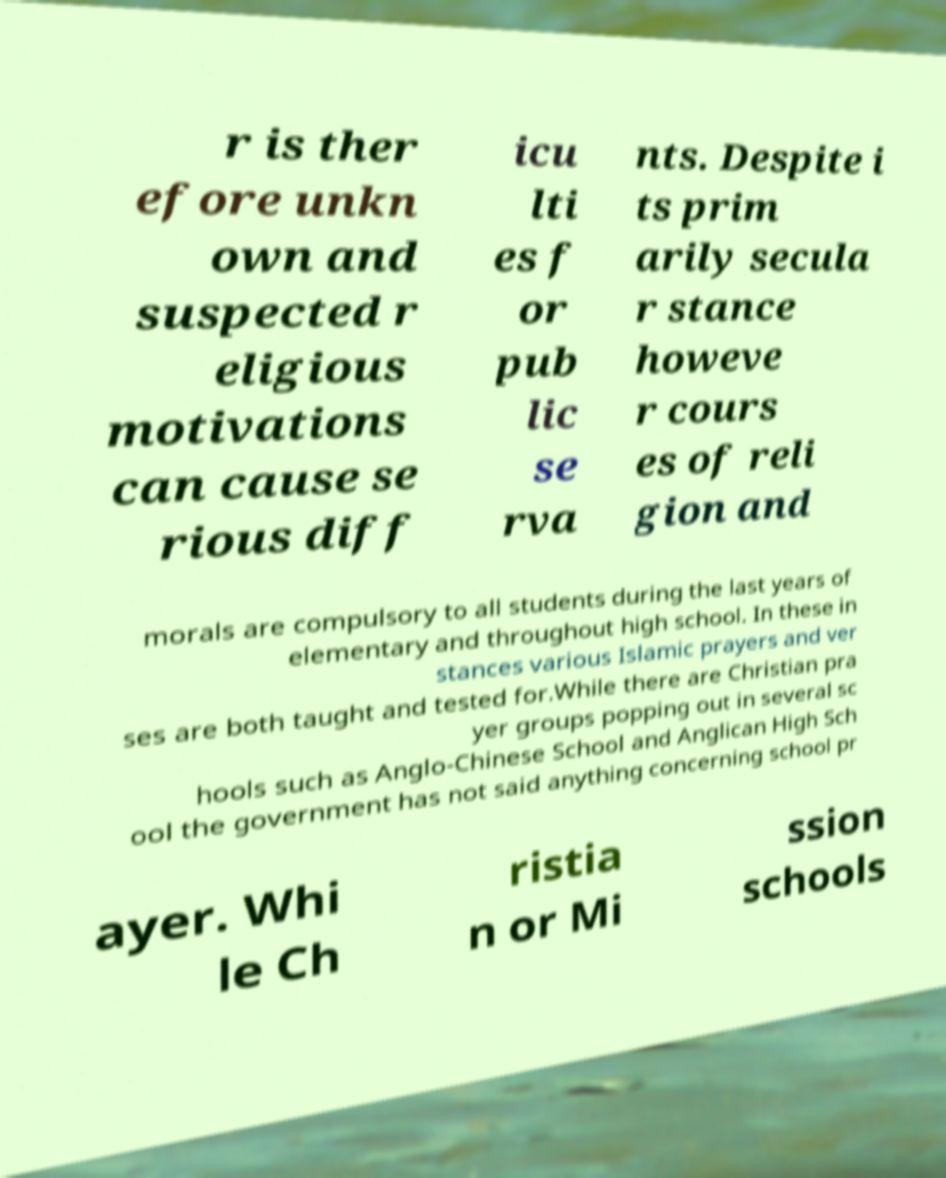I need the written content from this picture converted into text. Can you do that? r is ther efore unkn own and suspected r eligious motivations can cause se rious diff icu lti es f or pub lic se rva nts. Despite i ts prim arily secula r stance howeve r cours es of reli gion and morals are compulsory to all students during the last years of elementary and throughout high school. In these in stances various Islamic prayers and ver ses are both taught and tested for.While there are Christian pra yer groups popping out in several sc hools such as Anglo-Chinese School and Anglican High Sch ool the government has not said anything concerning school pr ayer. Whi le Ch ristia n or Mi ssion schools 